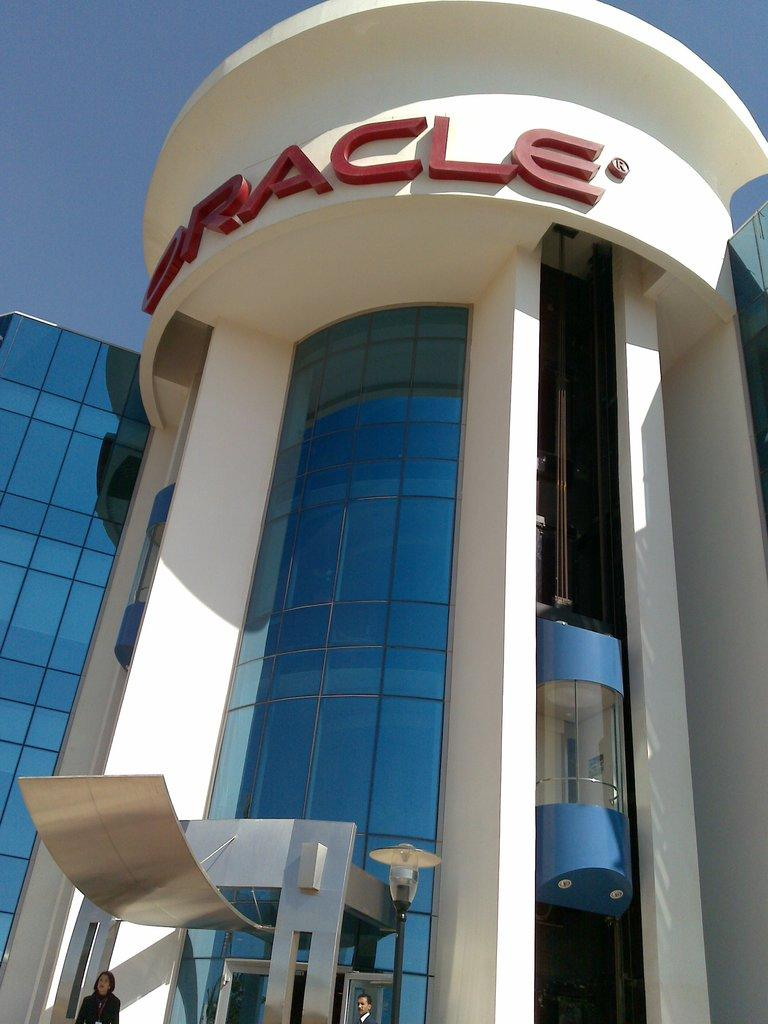What type of structure is visible in the image? There is a building in the image. Can you describe the people at the bottom of the image? There are people at the bottom of the image, but their specific actions or characteristics are not mentioned in the facts. What feature is located on the right side of the image? There is a lift on the right side of the image. What is written or displayed at the top of the image? There is text at the top of the image. What type of stitch is used to repair the skin of the people in the image? There is no mention of any injuries or skin repair in the image, so it is not possible to determine the type of stitch used. 